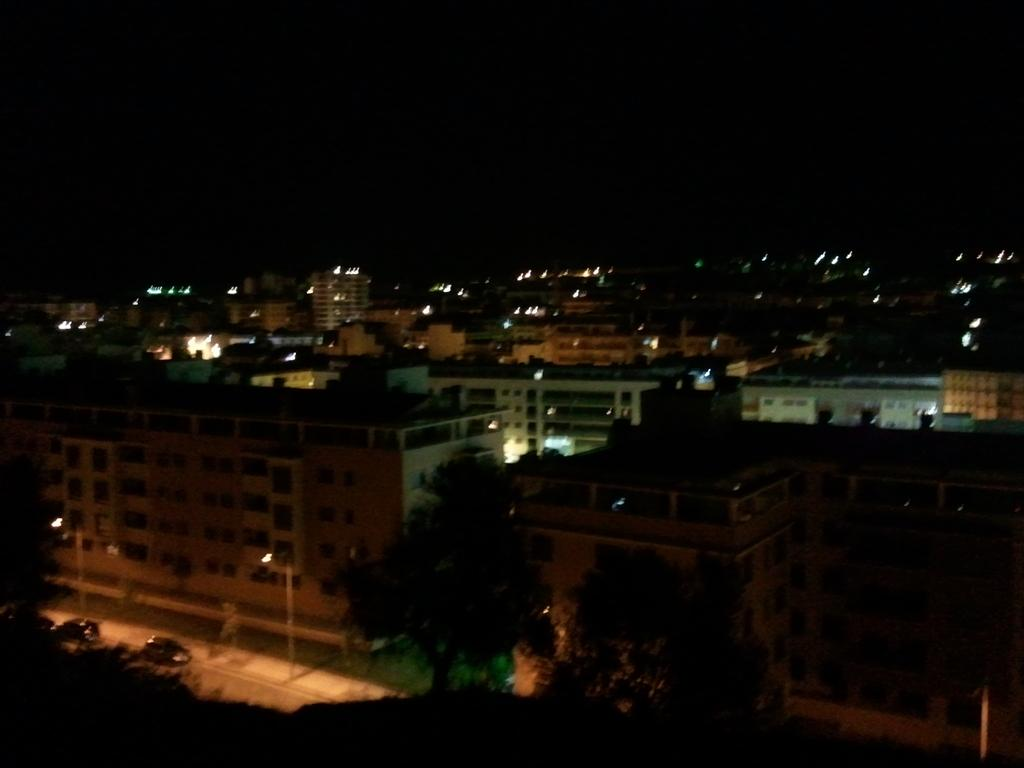What type of location is depicted in the image? The image shows a view of a city. What structures can be seen in the image? There are buildings in the image. Are there any illuminated objects in the image? Yes, there are lights in the image. What type of natural elements can be seen in the image? There are trees in the image. How many cars are visible on the road in the image? There are two cars on the road in the image. How would you describe the overall lighting in the image? The background appears dark in the image. What type of bears can be seen interacting with the trees in the image? There are no bears present in the image; it depicts a cityscape with trees. What sense is being utilized by the cars on the road in the image? The question is not applicable, as cars do not have senses; they are inanimate objects. 